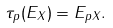<formula> <loc_0><loc_0><loc_500><loc_500>\tau _ { p } ( E _ { X } ) = E _ { p X } .</formula> 